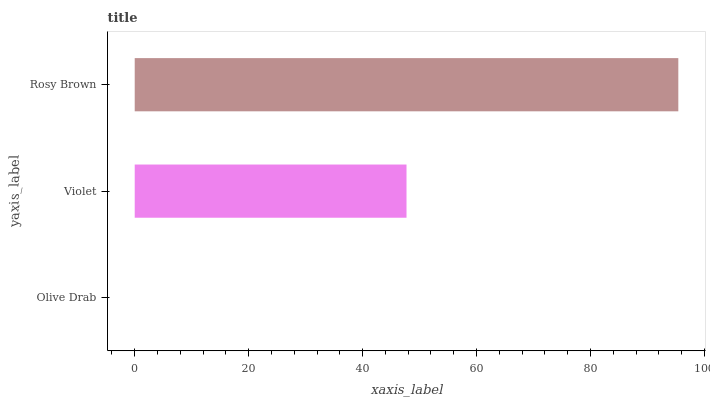Is Olive Drab the minimum?
Answer yes or no. Yes. Is Rosy Brown the maximum?
Answer yes or no. Yes. Is Violet the minimum?
Answer yes or no. No. Is Violet the maximum?
Answer yes or no. No. Is Violet greater than Olive Drab?
Answer yes or no. Yes. Is Olive Drab less than Violet?
Answer yes or no. Yes. Is Olive Drab greater than Violet?
Answer yes or no. No. Is Violet less than Olive Drab?
Answer yes or no. No. Is Violet the high median?
Answer yes or no. Yes. Is Violet the low median?
Answer yes or no. Yes. Is Olive Drab the high median?
Answer yes or no. No. Is Rosy Brown the low median?
Answer yes or no. No. 